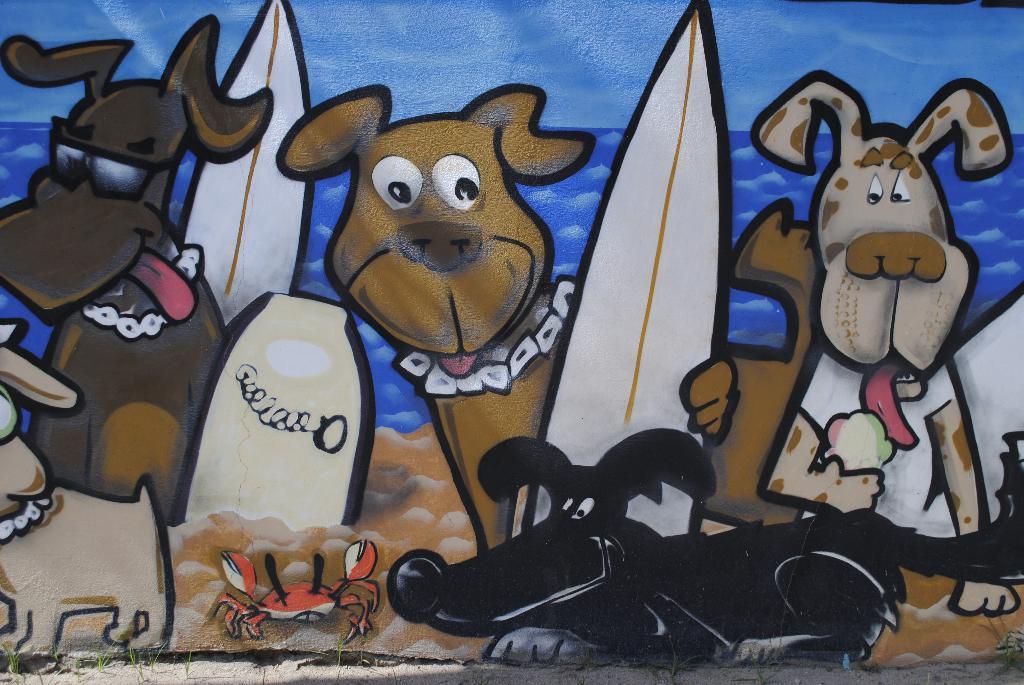Describe this image in one or two sentences. In this image there is a painting on the wall. 